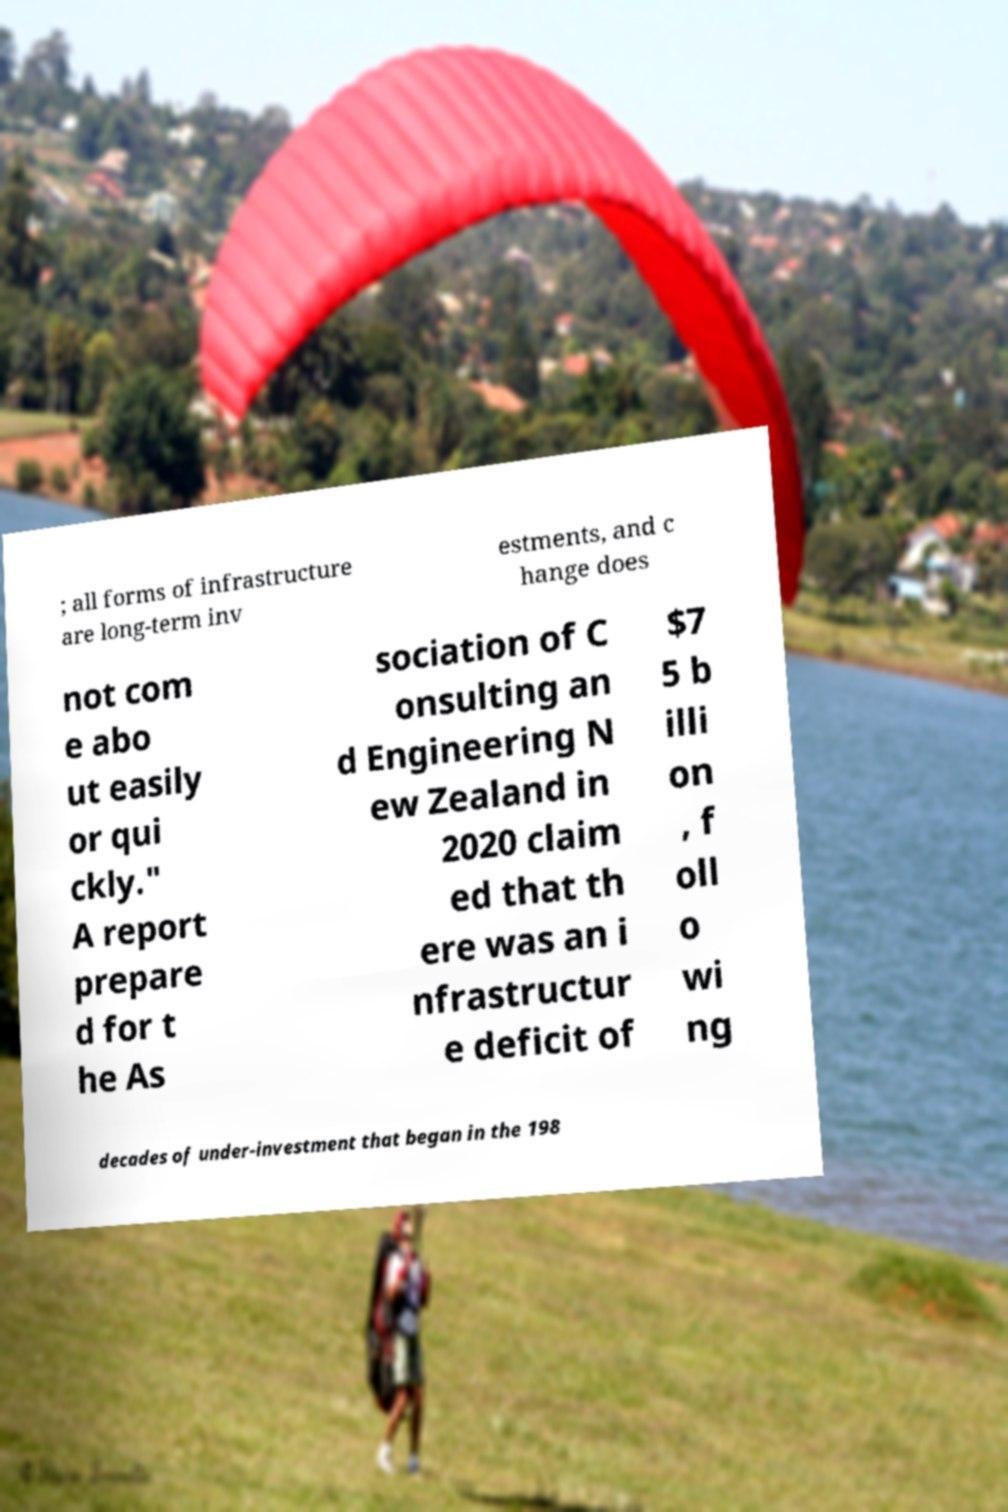There's text embedded in this image that I need extracted. Can you transcribe it verbatim? ; all forms of infrastructure are long-term inv estments, and c hange does not com e abo ut easily or qui ckly." A report prepare d for t he As sociation of C onsulting an d Engineering N ew Zealand in 2020 claim ed that th ere was an i nfrastructur e deficit of $7 5 b illi on , f oll o wi ng decades of under-investment that began in the 198 